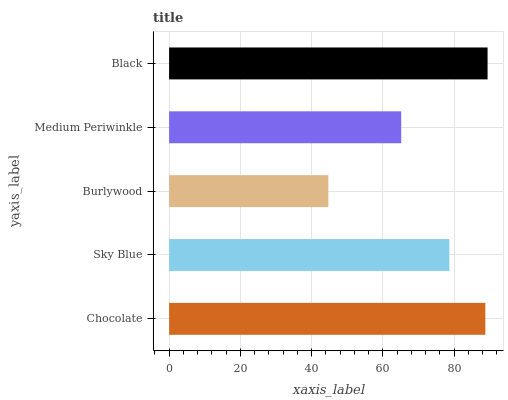Is Burlywood the minimum?
Answer yes or no. Yes. Is Black the maximum?
Answer yes or no. Yes. Is Sky Blue the minimum?
Answer yes or no. No. Is Sky Blue the maximum?
Answer yes or no. No. Is Chocolate greater than Sky Blue?
Answer yes or no. Yes. Is Sky Blue less than Chocolate?
Answer yes or no. Yes. Is Sky Blue greater than Chocolate?
Answer yes or no. No. Is Chocolate less than Sky Blue?
Answer yes or no. No. Is Sky Blue the high median?
Answer yes or no. Yes. Is Sky Blue the low median?
Answer yes or no. Yes. Is Black the high median?
Answer yes or no. No. Is Chocolate the low median?
Answer yes or no. No. 